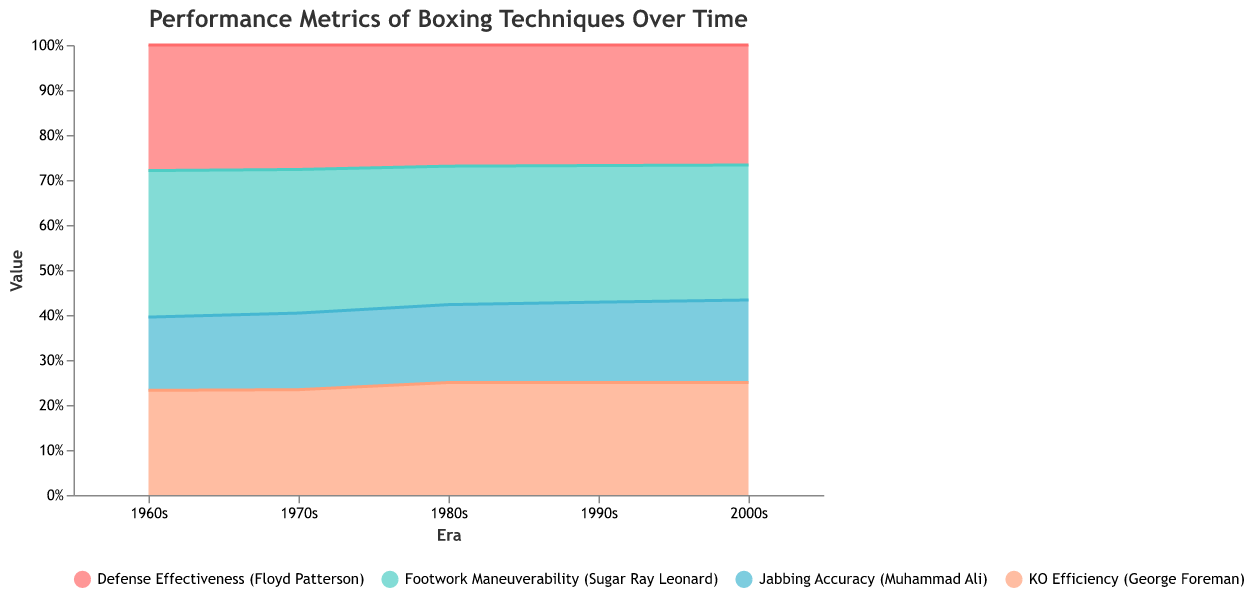What is the title of the chart? The title of the chart is displayed at the top and reads "Performance Metrics of Boxing Techniques Over Time".
Answer: Performance Metrics of Boxing Techniques Over Time What are the four techniques shown in the chart? The four techniques are depicted using different colors and are listed in the legend at the bottom. They are "Jabbing Accuracy (Muhammad Ali)", "KO Efficiency (George Foreman)", "Defense Effectiveness (Floyd Patterson)", and "Footwork Maneuverability (Sugar Ray Leonard)".
Answer: Jabbing Accuracy (Muhammad Ali), KO Efficiency (George Foreman), Defense Effectiveness (Floyd Patterson), Footwork Maneuverability (Sugar Ray Leonard) Which technique had the highest value in the 2000s? To answer this, we need to look at the rightmost side of the chart (2000s era) and identify the topmost segment of the stacked area for that timeframe. "Footwork Maneuverability (Sugar Ray Leonard)" has the highest value in the 2000s.
Answer: Footwork Maneuverability (Sugar Ray Leonard) How has the "KO Efficiency (George Foreman)" progressed over different eras? To determine this, we need to trace the segment associated with "KO Efficiency (George Foreman)" over the eras from 1960s to 2000s. This technique's value has increased progressively from 0.50 in the 1960s to 0.80 in the 2000s.
Answer: Increased from 0.50 to 0.80 In which era did "Defense Effectiveness (Floyd Patterson)" and "Footwork Maneuverability (Sugar Ray Leonard)" have equal effectiveness? We need to identify the era where the two segments indicating these techniques meet across the chart. In the 1970s, the effectiveness of both techniques was at 0.65.
Answer: 1970s What is the sum of "Jabbing Accuracy (Muhammad Ali)" and "KO Efficiency (George Foreman)" in the 1980s? The value of "Jabbing Accuracy (Muhammad Ali)" in the 1980s is 0.45, and the value of "KO Efficiency (George Foreman)" in the same period is 0.65. Adding these values gives us 0.45 + 0.65 = 1.10.
Answer: 1.10 Which technique showed the least improvement over time? By examining the changes in the values of each technique from the 1960s to the 2000s, "Jabbing Accuracy (Muhammad Ali)" shows the least improvement, increasing by only 0.25 (from 0.35 to 0.60)
Answer: Jabbing Accuracy (Muhammad Ali) Which era showed the greatest combined effectiveness from all techniques? We need to compare the total stacked height of the segments for each era. The 2000s have the highest combined total effectiveness.
Answer: 2000s Considering both "Defense Effectiveness (Floyd Patterson)" and "KO Efficiency (George Foreman)", in which era was their combined total the lowest? To answer this, we have to add the values of these two techniques across different eras and find where their combined effectiveness is the lowest. In the 1960s, combined effectiveness is 0.60 + 0.50 = 1.10.
Answer: 1960s 